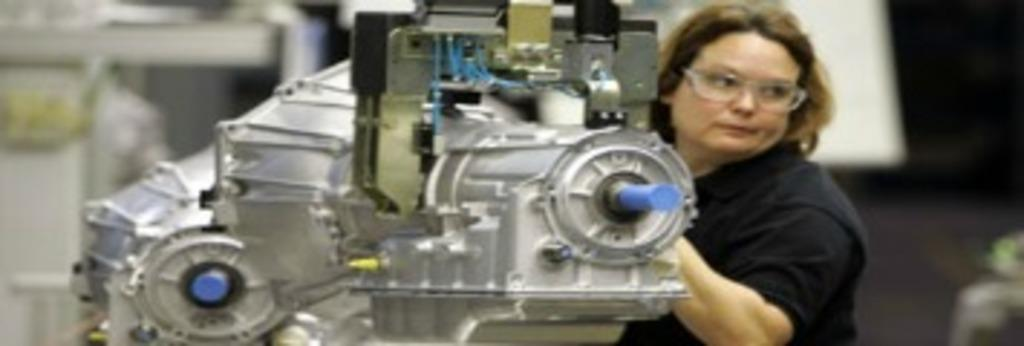Who is present in the image? There is a woman in the image. What is the woman doing in the image? The woman is standing in the image. What accessory is the woman wearing? The woman is wearing spectacles in the image. What else can be seen in the image besides the woman? There are machines visible in the image. What type of houses can be seen in the background of the image? There are no houses visible in the image; it only features a woman and machines. 